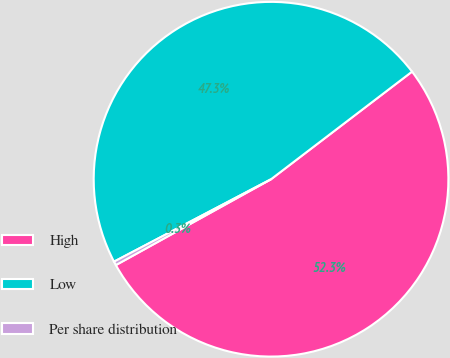<chart> <loc_0><loc_0><loc_500><loc_500><pie_chart><fcel>High<fcel>Low<fcel>Per share distribution<nl><fcel>52.33%<fcel>47.32%<fcel>0.35%<nl></chart> 